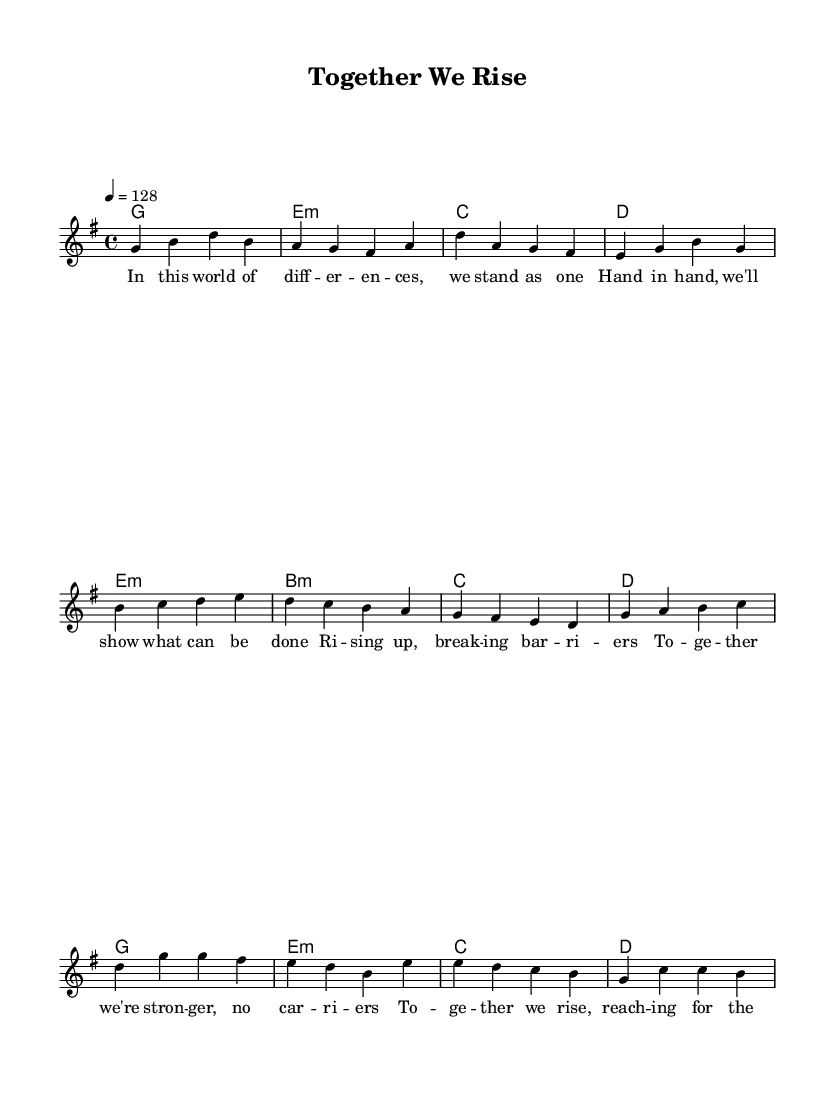What is the key signature of this music? The key signature is indicated at the beginning of the piece. In this case, it shows one sharp (F#), which corresponds to the key of G major.
Answer: G major What is the time signature of this music? The time signature appears near the beginning of the score. Here, it is written as 4/4, which means there are four beats in a measure with the quarter note receiving one beat.
Answer: 4/4 What is the tempo marking of this music? The tempo marking indicates the speed of the piece. Here, it is shown as "4 = 128," meaning the quarter note should be played at a rate of 128 beats per minute.
Answer: 128 How many sections are there in the piece? By analyzing the structure presented, there are three distinct sections identified: the verse, pre-chorus, and chorus.
Answer: Three What is the theme of the lyrics? The lyrics reflect a message of unity and resilience, emphasizing coming together to achieve dreams and break barriers.
Answer: Unity What chord is played during the chorus? The chord played during the chorus is indicated in the harmony section above the melody. It starts with the G major chord followed by E minor, C major, and D major.
Answer: G, E minor, C, D How does the pre-chorus connect with the chorus? The pre-chorus builds towards the chorus by creating a sense of anticipation and strength, leading into the uplifting message of unity in the chorus. This is shown through the lyrics and the musical progression.
Answer: By building anticipation 